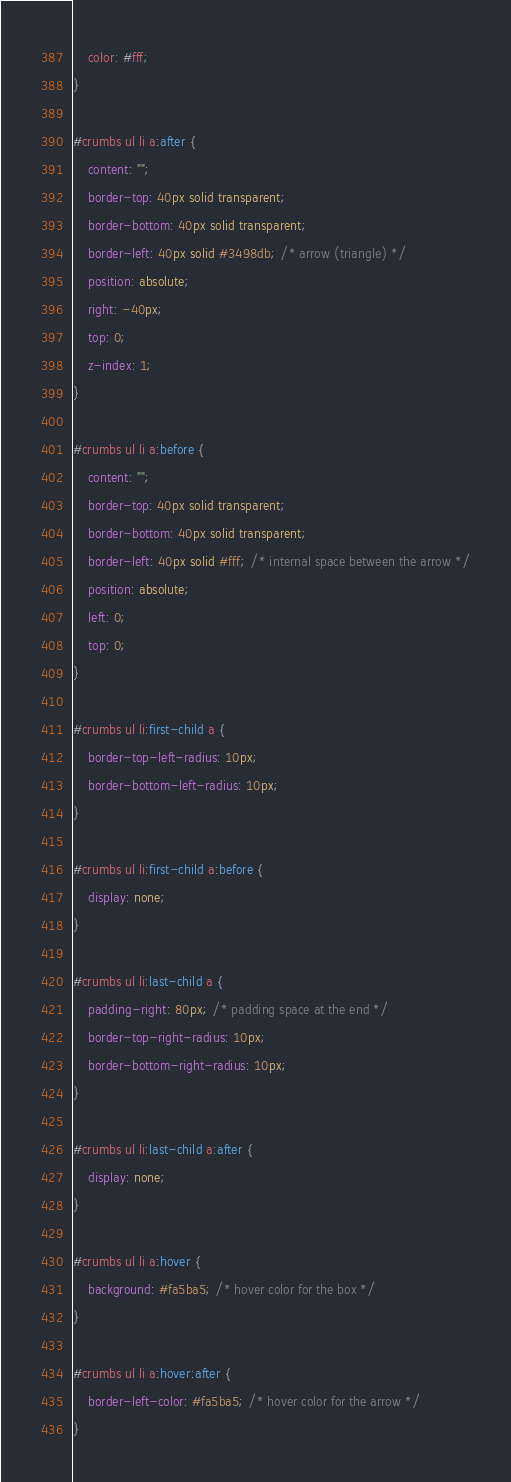<code> <loc_0><loc_0><loc_500><loc_500><_CSS_>    color: #fff;
}

#crumbs ul li a:after {
    content: "";
    border-top: 40px solid transparent;
    border-bottom: 40px solid transparent;
    border-left: 40px solid #3498db; /* arrow (triangle) */
    position: absolute;
    right: -40px;
    top: 0;
    z-index: 1;
}

#crumbs ul li a:before {
    content: "";
    border-top: 40px solid transparent;
    border-bottom: 40px solid transparent;
    border-left: 40px solid #fff; /* internal space between the arrow */
    position: absolute;
    left: 0;
    top: 0;
}

#crumbs ul li:first-child a {
    border-top-left-radius: 10px;
    border-bottom-left-radius: 10px;
}

#crumbs ul li:first-child a:before {
    display: none;
}

#crumbs ul li:last-child a {
    padding-right: 80px; /* padding space at the end */
    border-top-right-radius: 10px;
    border-bottom-right-radius: 10px;
}

#crumbs ul li:last-child a:after {
    display: none;
}

#crumbs ul li a:hover {
    background: #fa5ba5; /* hover color for the box */
}

#crumbs ul li a:hover:after {
    border-left-color: #fa5ba5; /* hover color for the arrow */
}</code> 